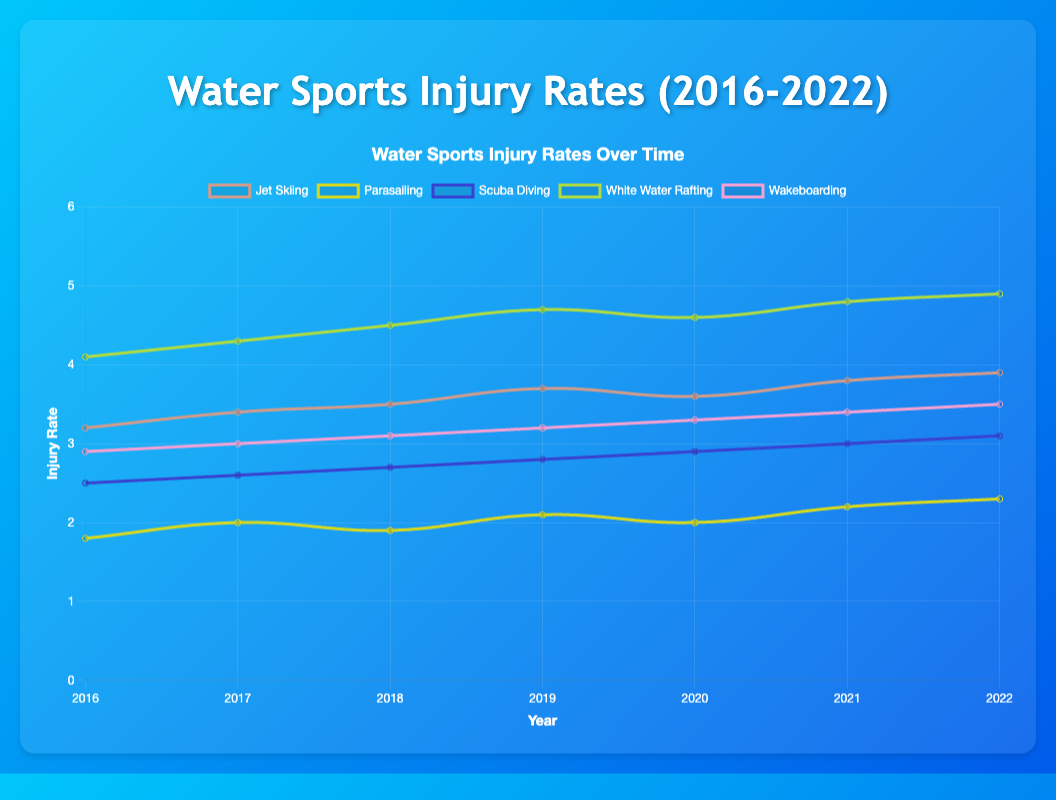What is the overall trend for Jet Skiing injury rates from 2016 to 2022? The line for Jet Skiing shows a consistently increasing trend in injury rates across the years 2016 to 2022.
Answer: Increasing trend Which water sport had the highest injury rate in 2022? In 2022, White Water Rafting had the highest injury rate, with the line at the 4.9 mark on the y-axis.
Answer: White Water Rafting For which years did Parasailing have the same injury rate? Parasailing had the same injury rate of 2.0 in both 2017 and 2020, as indicated by the lines touching the same y-axis value.
Answer: 2017 and 2020 How did the injury rate for Scuba Diving change from 2016 to 2022? The injury rate for Scuba Diving increased gradually from 2.5 in 2016 to 3.1 in 2022, with minor fluctuations each year.
Answer: It increased Which sport showed the most significant increase in injury rate between 2016 and 2022? Comparing the lines' start and end points, White Water Rafting had the most significant increase, going from 4.1 in 2016 to 4.9 in 2022.
Answer: White Water Rafting Compare the injury rates of Wakeboarding and Scuba Diving in 2020. Which one is higher? In 2020, the injury rate for Wakeboarding was 3.3 and for Scuba Diving was 2.9, as seen by the line heights. Wakeboarding had a higher injury rate.
Answer: Wakeboarding What is the average injury rate for Parasailing between 2016 and 2022? Adding the values for Parasailing (1.8, 2.0, 1.9, 2.1, 2.0, 2.2, 2.3) and dividing by 7 gives (1.8+2.0+1.9+2.1+2.0+2.2+2.3) / 7 = 2.043.
Answer: Approximately 2.04 During which year did White Water Rafting see its highest sequential increase in injury rate? The largest year-on-year increase for White Water Rafting was from 2018 (4.5) to 2019 (4.7), a change of 0.2.
Answer: Between 2018 and 2019 For Jet Skiing, which two consecutive years saw the smallest change in injury rates? The smallest change for Jet Skiing was between 2019 (3.7) and 2020 (3.6), a change of -0.1.
Answer: 2019 and 2020 Which year had the lowest overall injury rates across all sports and what might be the reason? In 2016, the injury rates were generally lower compared to other years. This can be observed since the starting points for many lines are towards the lower end of the y-axis.
Answer: 2016. Possible better safety protocols 